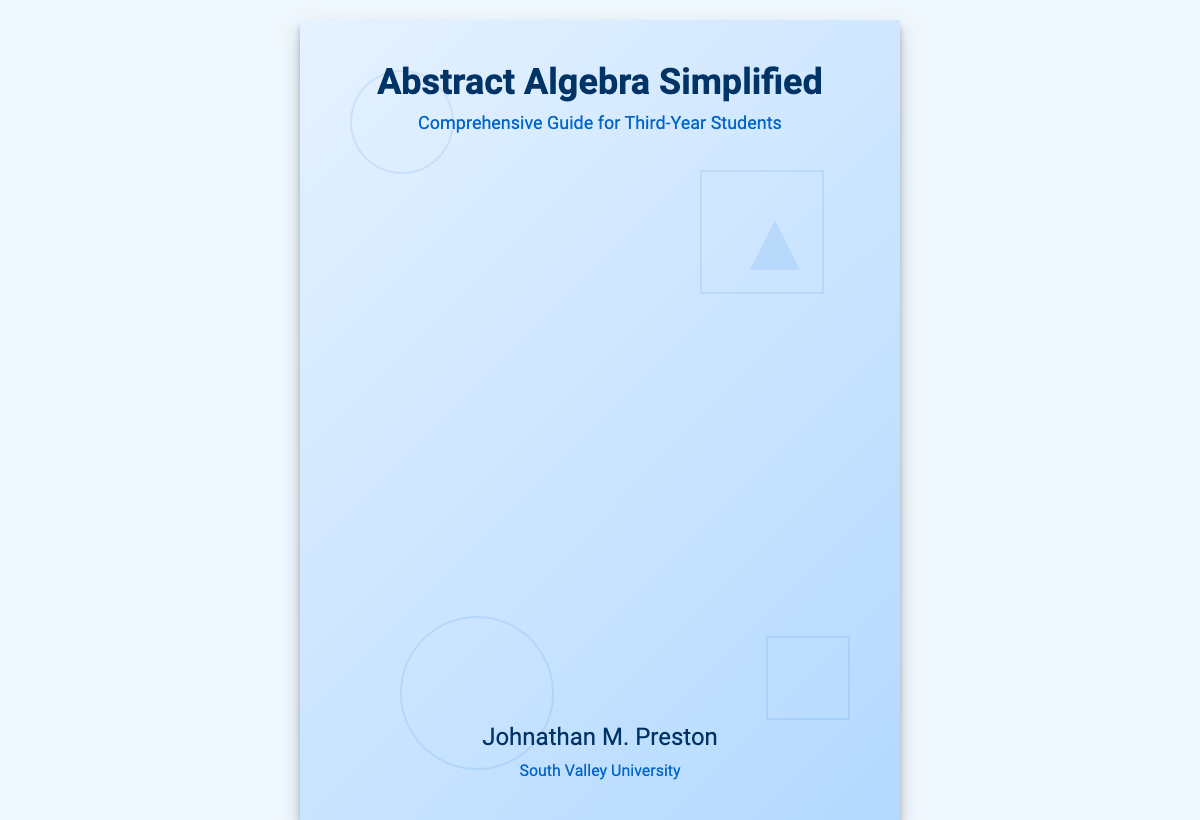What is the title of the book? The title of the book is prominently displayed at the top of the cover.
Answer: Abstract Algebra Simplified Who is the author of the book? The author's name is located at the bottom of the book cover.
Answer: Johnathan M. Preston What is the subtitle of the book? The subtitle provides additional context and is found just below the title.
Answer: Comprehensive Guide for Third-Year Students What is the institution associated with the author? The institution is indicated below the author's name on the cover.
Answer: South Valley University What geometric shape is at the top-left corner of the cover? The shapes on the cover include various geometric forms, with one shape being at that position.
Answer: Circle How many circles are present on the book cover? Counting the circles is necessary to answer this question based on visual information.
Answer: Two What color dominates the book cover's geometric shapes? The shapes on the cover use a consistent color theme.
Answer: Blue What is the primary background color of the cover? The background color can be identified quickly by observing the cover's base layer.
Answer: Light Blue 